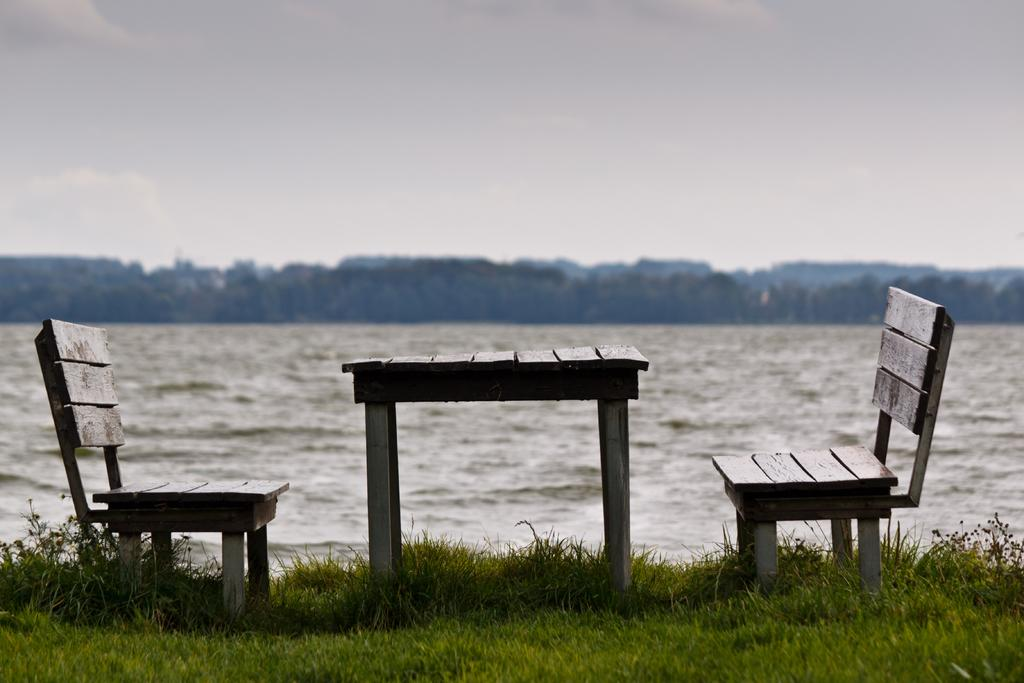What type of furniture is present in the image? There is a table and two benches in the image. What type of surface is the table and benches placed on? There is grass visible in the image, suggesting that the table and benches are placed on a grassy surface. What can be seen in the background of the image? There is water, trees, and a clear sky visible in the background of the image. How many islands can be seen in the image? There are no islands visible in the image. What type of group is sitting on the benches in the image? There are no people or groups present in the image, only the table and benches. 